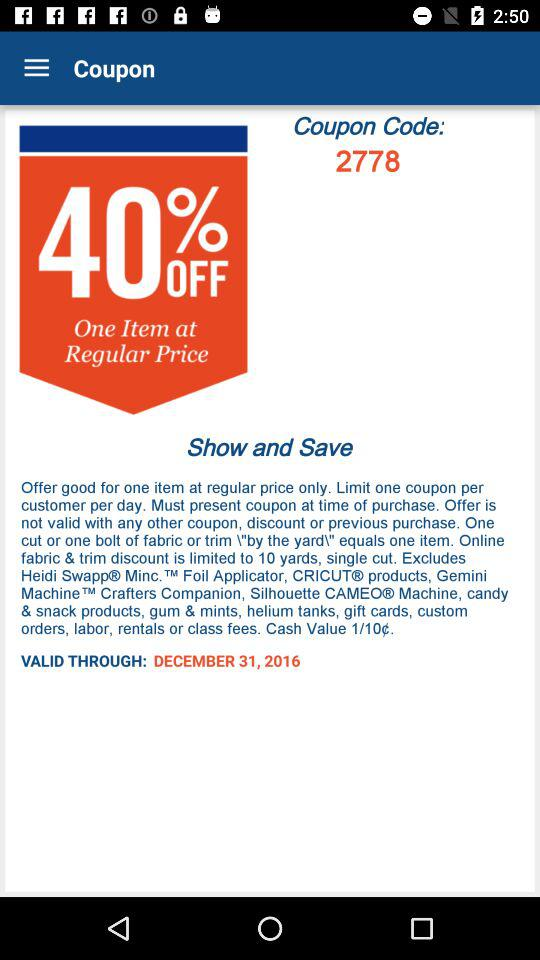What is the coupon code number? The code number is "2778". 